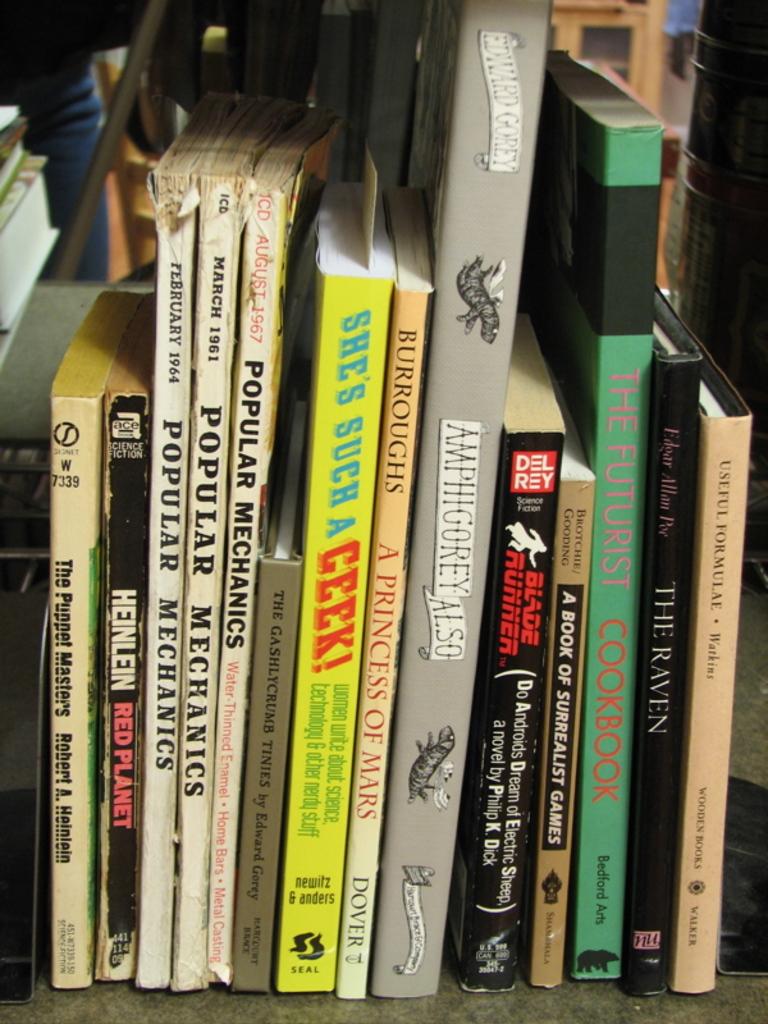What is the title of the novel on the shelf by philip k dick?
Offer a terse response. Blade runner. What magazine is from 1961?
Your answer should be very brief. Popular mechanics. 